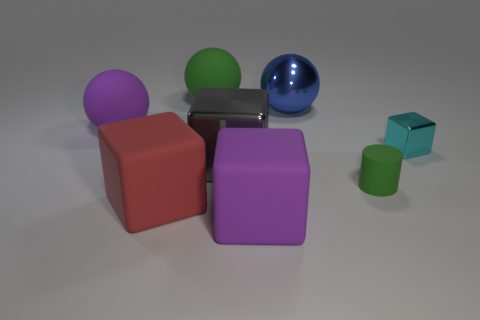There is a metal thing that is both left of the small green rubber thing and in front of the large purple sphere; how big is it?
Your response must be concise. Large. Is the number of large rubber cubes that are right of the green sphere less than the number of large green rubber balls?
Provide a succinct answer. No. What shape is the large green object that is the same material as the cylinder?
Provide a short and direct response. Sphere. There is a green thing that is in front of the small cube; does it have the same shape as the metal object that is in front of the cyan block?
Give a very brief answer. No. Is the number of large metallic cubes that are left of the big gray metal thing less than the number of objects that are in front of the tiny shiny object?
Give a very brief answer. Yes. There is a big matte object that is the same color as the tiny matte thing; what shape is it?
Give a very brief answer. Sphere. How many shiny cubes have the same size as the purple matte block?
Give a very brief answer. 1. Do the green object in front of the cyan thing and the large purple sphere have the same material?
Give a very brief answer. Yes. Is there a blue metallic ball?
Keep it short and to the point. Yes. What size is the green cylinder that is the same material as the red object?
Ensure brevity in your answer.  Small. 